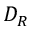Convert formula to latex. <formula><loc_0><loc_0><loc_500><loc_500>D _ { R }</formula> 